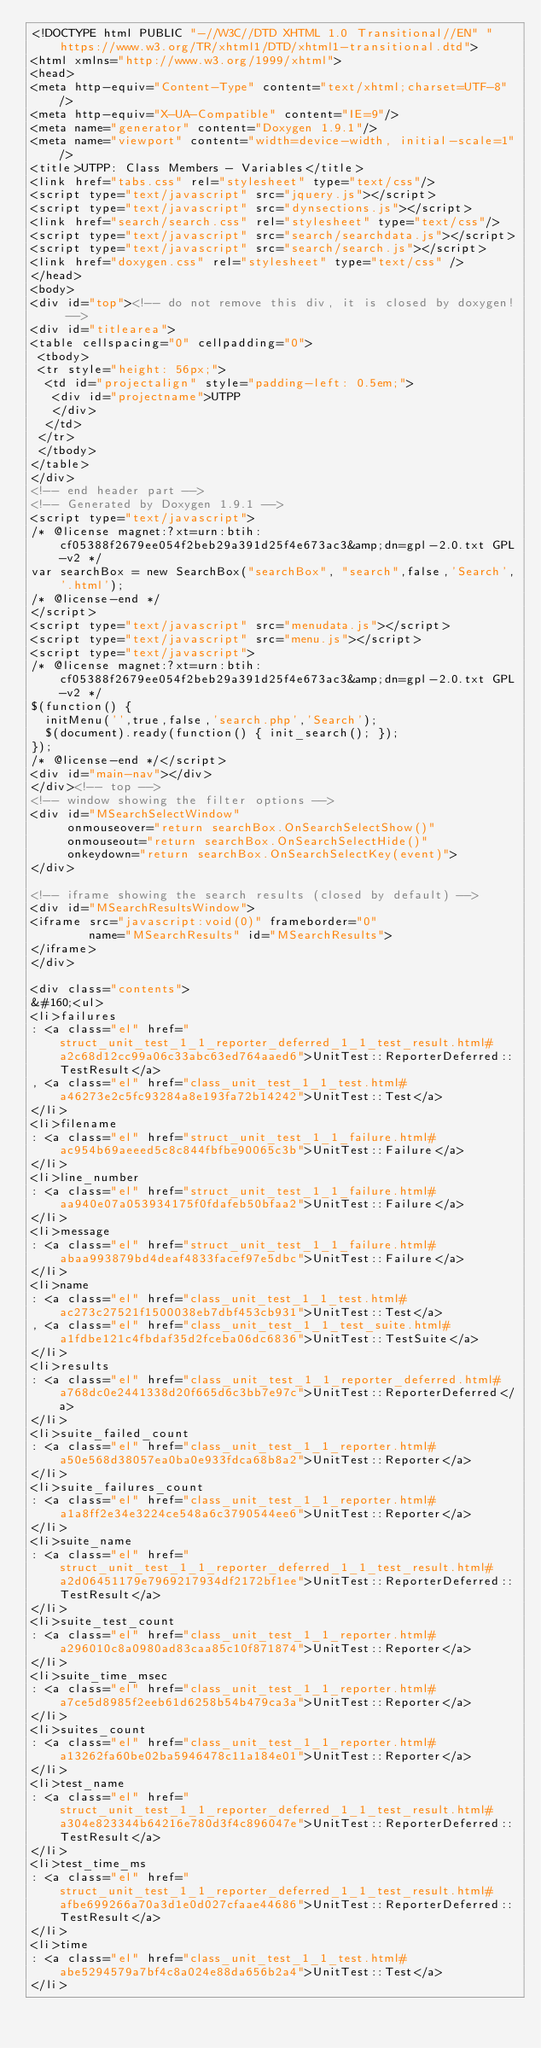<code> <loc_0><loc_0><loc_500><loc_500><_HTML_><!DOCTYPE html PUBLIC "-//W3C//DTD XHTML 1.0 Transitional//EN" "https://www.w3.org/TR/xhtml1/DTD/xhtml1-transitional.dtd">
<html xmlns="http://www.w3.org/1999/xhtml">
<head>
<meta http-equiv="Content-Type" content="text/xhtml;charset=UTF-8"/>
<meta http-equiv="X-UA-Compatible" content="IE=9"/>
<meta name="generator" content="Doxygen 1.9.1"/>
<meta name="viewport" content="width=device-width, initial-scale=1"/>
<title>UTPP: Class Members - Variables</title>
<link href="tabs.css" rel="stylesheet" type="text/css"/>
<script type="text/javascript" src="jquery.js"></script>
<script type="text/javascript" src="dynsections.js"></script>
<link href="search/search.css" rel="stylesheet" type="text/css"/>
<script type="text/javascript" src="search/searchdata.js"></script>
<script type="text/javascript" src="search/search.js"></script>
<link href="doxygen.css" rel="stylesheet" type="text/css" />
</head>
<body>
<div id="top"><!-- do not remove this div, it is closed by doxygen! -->
<div id="titlearea">
<table cellspacing="0" cellpadding="0">
 <tbody>
 <tr style="height: 56px;">
  <td id="projectalign" style="padding-left: 0.5em;">
   <div id="projectname">UTPP
   </div>
  </td>
 </tr>
 </tbody>
</table>
</div>
<!-- end header part -->
<!-- Generated by Doxygen 1.9.1 -->
<script type="text/javascript">
/* @license magnet:?xt=urn:btih:cf05388f2679ee054f2beb29a391d25f4e673ac3&amp;dn=gpl-2.0.txt GPL-v2 */
var searchBox = new SearchBox("searchBox", "search",false,'Search','.html');
/* @license-end */
</script>
<script type="text/javascript" src="menudata.js"></script>
<script type="text/javascript" src="menu.js"></script>
<script type="text/javascript">
/* @license magnet:?xt=urn:btih:cf05388f2679ee054f2beb29a391d25f4e673ac3&amp;dn=gpl-2.0.txt GPL-v2 */
$(function() {
  initMenu('',true,false,'search.php','Search');
  $(document).ready(function() { init_search(); });
});
/* @license-end */</script>
<div id="main-nav"></div>
</div><!-- top -->
<!-- window showing the filter options -->
<div id="MSearchSelectWindow"
     onmouseover="return searchBox.OnSearchSelectShow()"
     onmouseout="return searchBox.OnSearchSelectHide()"
     onkeydown="return searchBox.OnSearchSelectKey(event)">
</div>

<!-- iframe showing the search results (closed by default) -->
<div id="MSearchResultsWindow">
<iframe src="javascript:void(0)" frameborder="0" 
        name="MSearchResults" id="MSearchResults">
</iframe>
</div>

<div class="contents">
&#160;<ul>
<li>failures
: <a class="el" href="struct_unit_test_1_1_reporter_deferred_1_1_test_result.html#a2c68d12cc99a06c33abc63ed764aaed6">UnitTest::ReporterDeferred::TestResult</a>
, <a class="el" href="class_unit_test_1_1_test.html#a46273e2c5fc93284a8e193fa72b14242">UnitTest::Test</a>
</li>
<li>filename
: <a class="el" href="struct_unit_test_1_1_failure.html#ac954b69aeeed5c8c844fbfbe90065c3b">UnitTest::Failure</a>
</li>
<li>line_number
: <a class="el" href="struct_unit_test_1_1_failure.html#aa940e07a053934175f0fdafeb50bfaa2">UnitTest::Failure</a>
</li>
<li>message
: <a class="el" href="struct_unit_test_1_1_failure.html#abaa993879bd4deaf4833facef97e5dbc">UnitTest::Failure</a>
</li>
<li>name
: <a class="el" href="class_unit_test_1_1_test.html#ac273c27521f1500038eb7dbf453cb931">UnitTest::Test</a>
, <a class="el" href="class_unit_test_1_1_test_suite.html#a1fdbe121c4fbdaf35d2fceba06dc6836">UnitTest::TestSuite</a>
</li>
<li>results
: <a class="el" href="class_unit_test_1_1_reporter_deferred.html#a768dc0e2441338d20f665d6c3bb7e97c">UnitTest::ReporterDeferred</a>
</li>
<li>suite_failed_count
: <a class="el" href="class_unit_test_1_1_reporter.html#a50e568d38057ea0ba0e933fdca68b8a2">UnitTest::Reporter</a>
</li>
<li>suite_failures_count
: <a class="el" href="class_unit_test_1_1_reporter.html#a1a8ff2e34e3224ce548a6c3790544ee6">UnitTest::Reporter</a>
</li>
<li>suite_name
: <a class="el" href="struct_unit_test_1_1_reporter_deferred_1_1_test_result.html#a2d06451179e7969217934df2172bf1ee">UnitTest::ReporterDeferred::TestResult</a>
</li>
<li>suite_test_count
: <a class="el" href="class_unit_test_1_1_reporter.html#a296010c8a0980ad83caa85c10f871874">UnitTest::Reporter</a>
</li>
<li>suite_time_msec
: <a class="el" href="class_unit_test_1_1_reporter.html#a7ce5d8985f2eeb61d6258b54b479ca3a">UnitTest::Reporter</a>
</li>
<li>suites_count
: <a class="el" href="class_unit_test_1_1_reporter.html#a13262fa60be02ba5946478c11a184e01">UnitTest::Reporter</a>
</li>
<li>test_name
: <a class="el" href="struct_unit_test_1_1_reporter_deferred_1_1_test_result.html#a304e823344b64216e780d3f4c896047e">UnitTest::ReporterDeferred::TestResult</a>
</li>
<li>test_time_ms
: <a class="el" href="struct_unit_test_1_1_reporter_deferred_1_1_test_result.html#afbe699266a70a3d1e0d027cfaae44686">UnitTest::ReporterDeferred::TestResult</a>
</li>
<li>time
: <a class="el" href="class_unit_test_1_1_test.html#abe5294579a7bf4c8a024e88da656b2a4">UnitTest::Test</a>
</li></code> 